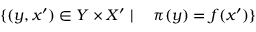Convert formula to latex. <formula><loc_0><loc_0><loc_500><loc_500>\{ ( y , x ^ { \prime } ) \in Y \times X ^ { \prime } | \quad \pi ( y ) = f ( x ^ { \prime } ) \}</formula> 